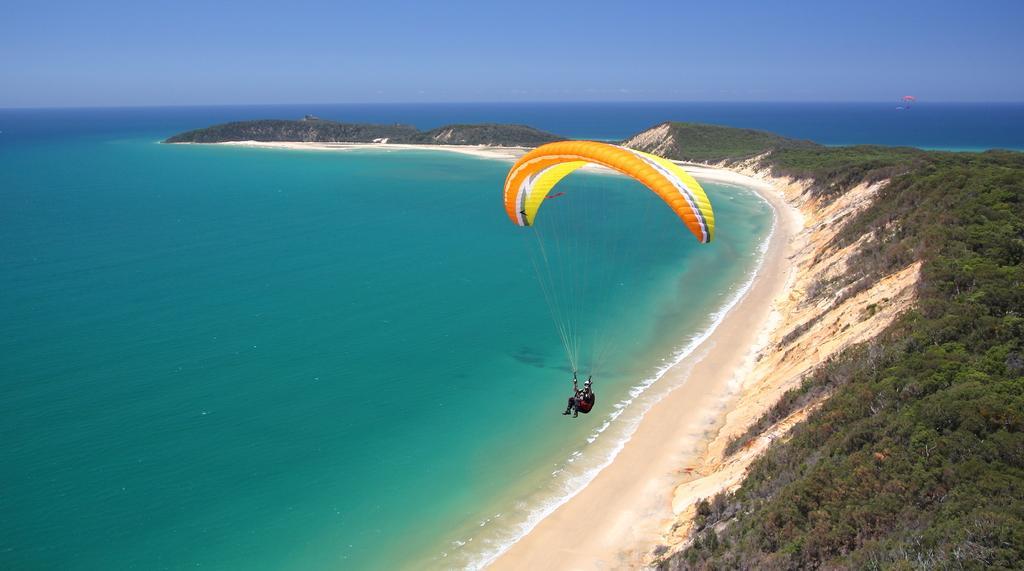In one or two sentences, can you explain what this image depicts? In this picture I can see a person parachuting with a parachute, there is water, trees, there is another parachute, and in the background there is sky. 